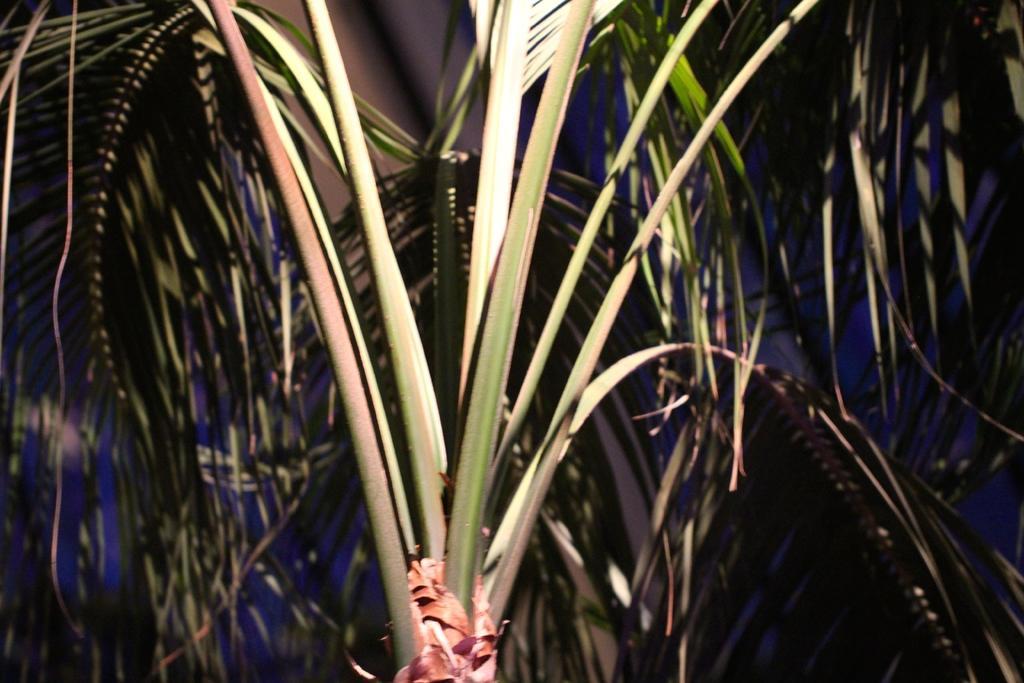How would you summarize this image in a sentence or two? In this image I can see the tree which is in green color. And there is a sky in the back. 